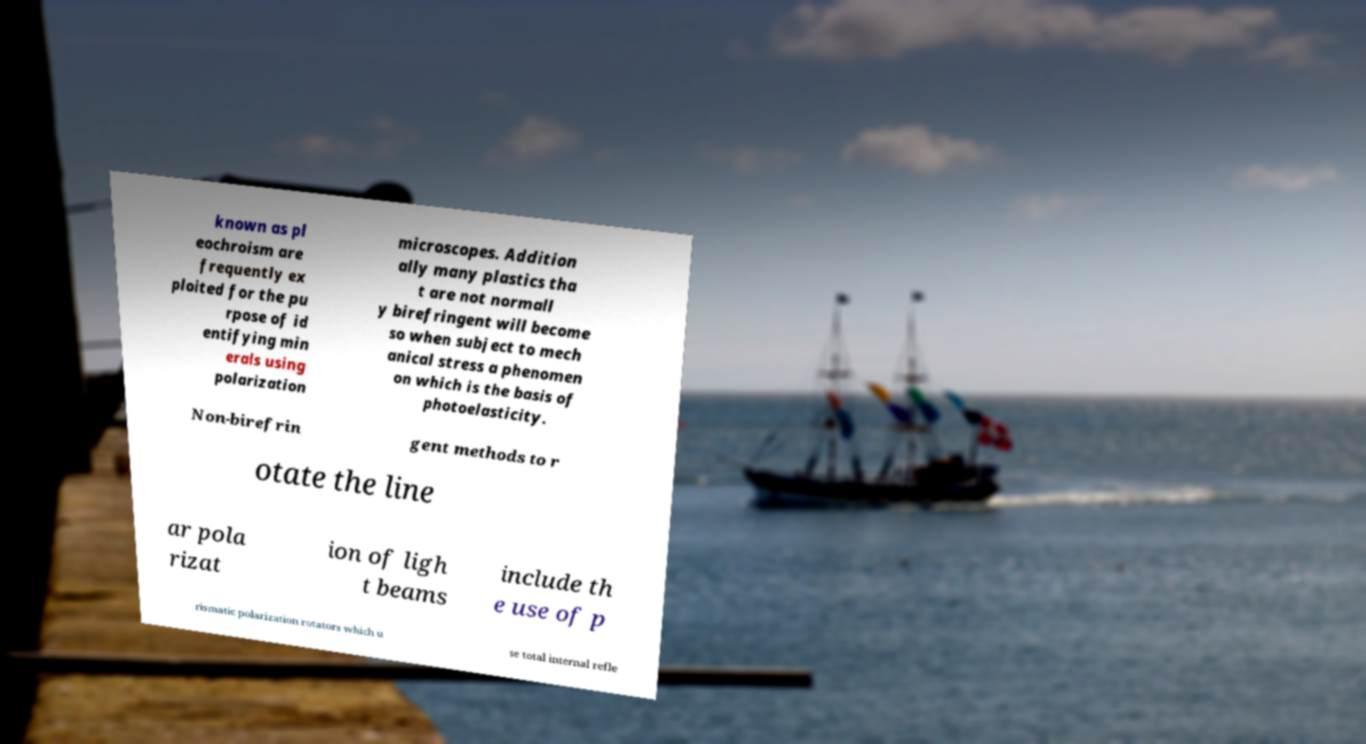There's text embedded in this image that I need extracted. Can you transcribe it verbatim? known as pl eochroism are frequently ex ploited for the pu rpose of id entifying min erals using polarization microscopes. Addition ally many plastics tha t are not normall y birefringent will become so when subject to mech anical stress a phenomen on which is the basis of photoelasticity. Non-birefrin gent methods to r otate the line ar pola rizat ion of ligh t beams include th e use of p rismatic polarization rotators which u se total internal refle 